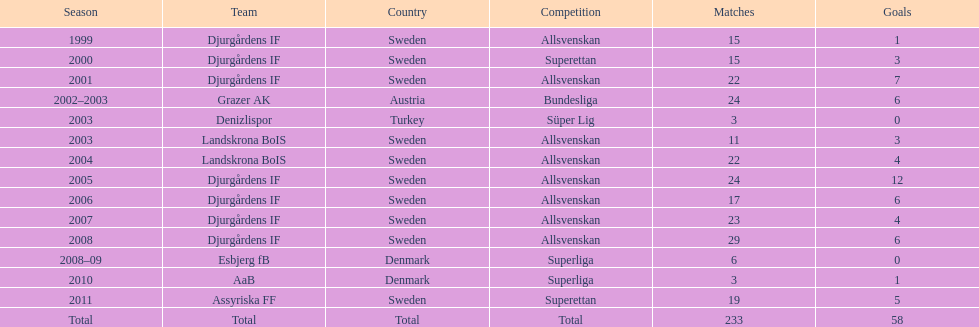How many matches overall were there? 233. 